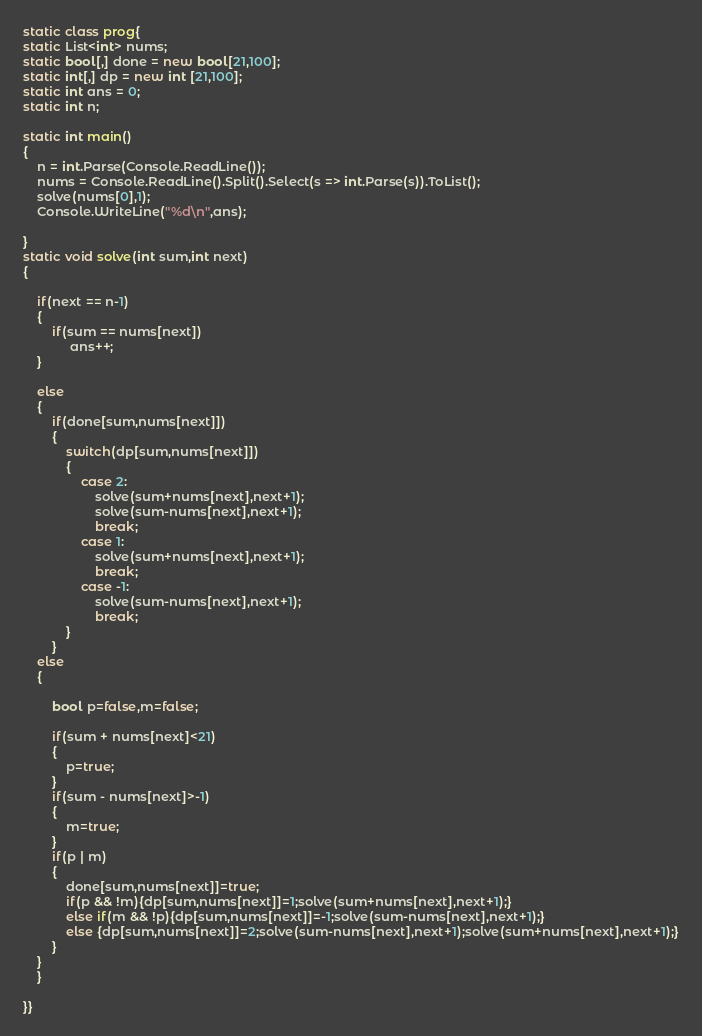Convert code to text. <code><loc_0><loc_0><loc_500><loc_500><_C#_>


static class prog{
static List<int> nums;
static bool[,] done = new bool[21,100];
static int[,] dp = new int [21,100];
static int ans = 0;
static int n;

static int main()
{
    n = int.Parse(Console.ReadLine());
    nums = Console.ReadLine().Split().Select(s => int.Parse(s)).ToList();
    solve(nums[0],1);
    Console.WriteLine("%d\n",ans);

}
static void solve(int sum,int next)
{

    if(next == n-1)
    {
        if(sum == nums[next])
             ans++;
    }

    else
    {
        if(done[sum,nums[next]])
        {
            switch(dp[sum,nums[next]])
            {
                case 2:
                    solve(sum+nums[next],next+1);
                    solve(sum-nums[next],next+1);
                    break;
                case 1:
                    solve(sum+nums[next],next+1);
                    break;
                case -1:
                    solve(sum-nums[next],next+1);
                    break;
            }
        }
	else
	{

        bool p=false,m=false;
     
        if(sum + nums[next]<21)
        {
            p=true;
        }
        if(sum - nums[next]>-1)
        {
            m=true;
        }
        if(p | m)
        {
            done[sum,nums[next]]=true;
            if(p && !m){dp[sum,nums[next]]=1;solve(sum+nums[next],next+1);}
            else if(m && !p){dp[sum,nums[next]]=-1;solve(sum-nums[next],next+1);}
            else {dp[sum,nums[next]]=2;solve(sum-nums[next],next+1);solve(sum+nums[next],next+1);}
        }
	}
    }

}}</code> 